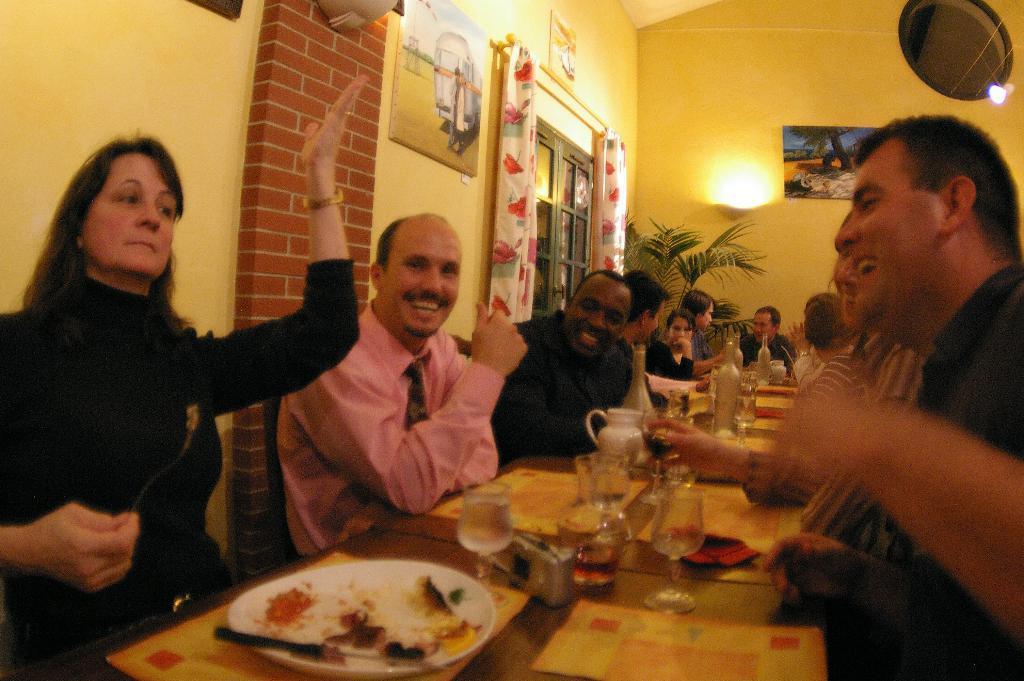Could you give a brief overview of what you see in this image? In this image we can see a group of people sitting beside a table containing some plates, spoons, glasses, a camera, napkins, a jar and some bottles on it. We can also see some photo frames and a hole on a wall. We can also see a plant, light and a door with the curtains. 